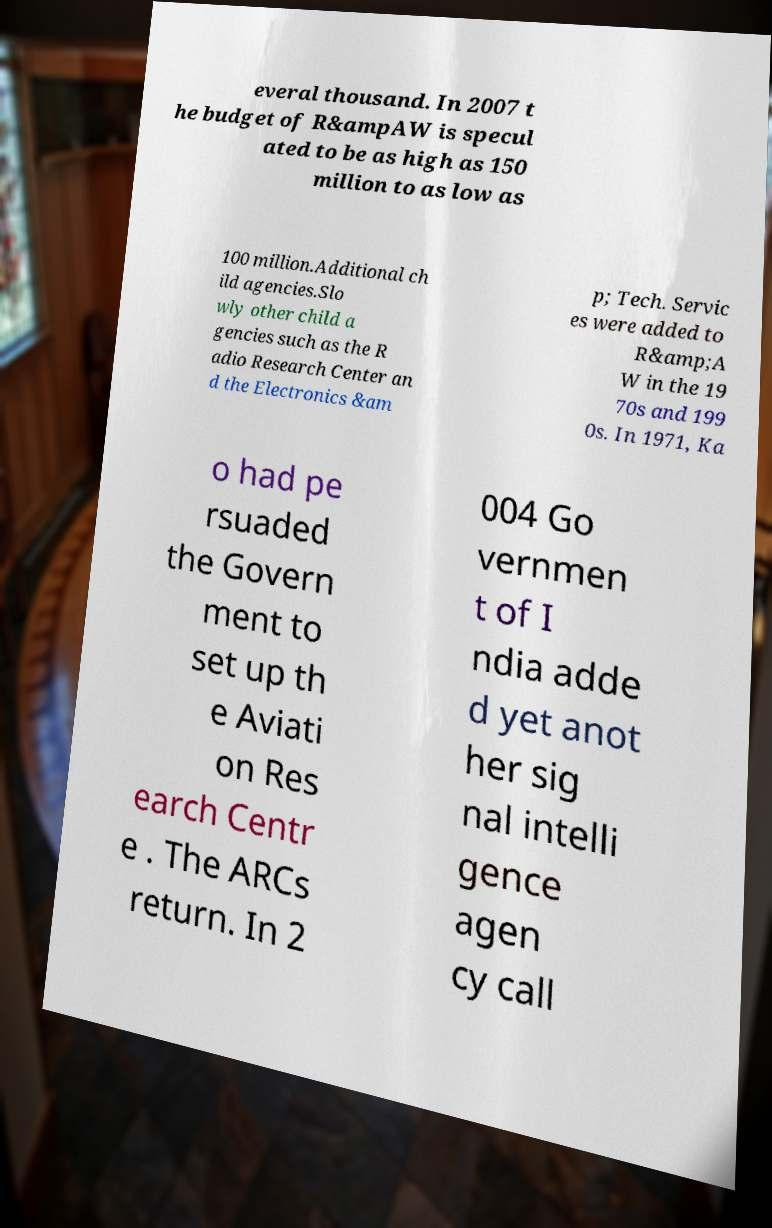Can you accurately transcribe the text from the provided image for me? everal thousand. In 2007 t he budget of R&ampAW is specul ated to be as high as 150 million to as low as 100 million.Additional ch ild agencies.Slo wly other child a gencies such as the R adio Research Center an d the Electronics &am p; Tech. Servic es were added to R&amp;A W in the 19 70s and 199 0s. In 1971, Ka o had pe rsuaded the Govern ment to set up th e Aviati on Res earch Centr e . The ARCs return. In 2 004 Go vernmen t of I ndia adde d yet anot her sig nal intelli gence agen cy call 